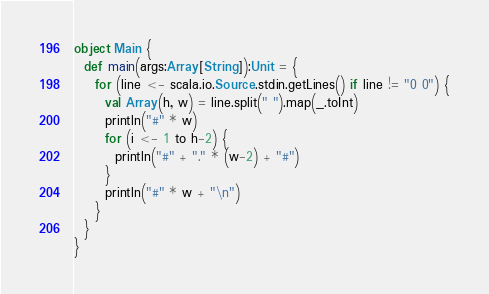<code> <loc_0><loc_0><loc_500><loc_500><_Scala_>object Main {
  def main(args:Array[String]):Unit = {
    for (line <- scala.io.Source.stdin.getLines() if line != "0 0") {
      val Array(h, w) = line.split(" ").map(_.toInt)
      println("#" * w)
      for (i <- 1 to h-2) {
        println("#" + "." * (w-2) + "#")
      }
      println("#" * w + "\n")
    }
  }
}</code> 